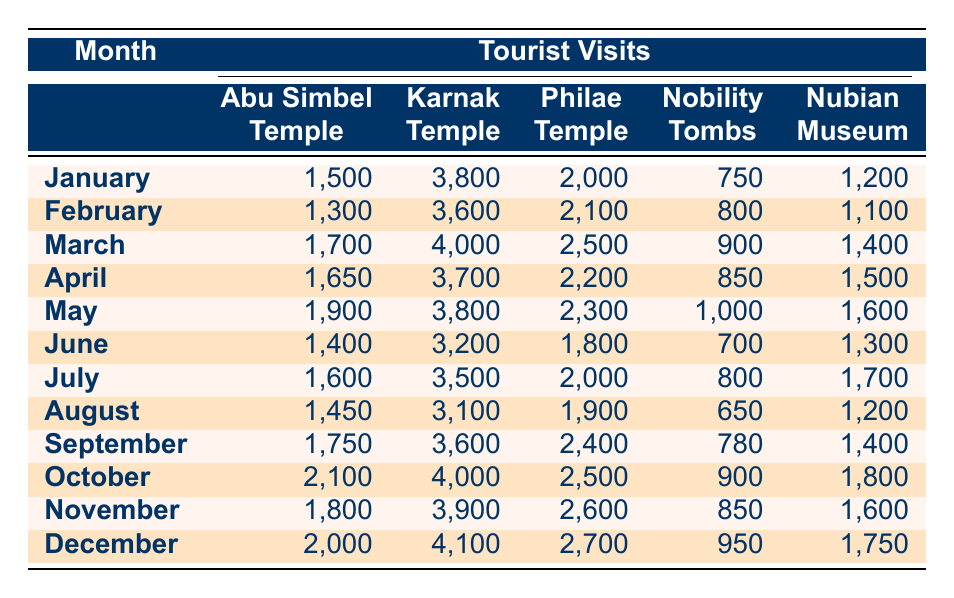What month had the highest number of visits to the Karnak Temple? In the table, I look for the maximum value under the Karnak Temple column. The highest number is 4100, which occurs in December.
Answer: December Which Nubian historical site received the least number of visitors in August? By examining the numbers in the August row, I see that the Nubian Museum received the least number of visitors with 1200.
Answer: Nubian Museum What is the total number of visits to Abu Simbel Temple from January to March? I sum the visitors: January (1500) + February (1300) + March (1700) = 4500 visitors in total.
Answer: 4500 Was there an increase in the number of visitors to the Philae Temple from June to July? I check the values: June had 1800 and July had 2000. The number has increased, confirming that more visitors came in July.
Answer: Yes What is the average number of visits to the Nobility Tombs across all months? To find the average, I add the visitors for each month: (750 + 800 + 900 + 850 + 1000 + 700 + 800 + 650 + 780 + 900 + 850 + 950) = 10,130. Then I divide this total by the number of months (12): 10,130 / 12 ≈ 844.17. Thus, the average is approximately 844.
Answer: 844 In which month did the Nubian Museum see a visitor count of 1700? Scanning through the row for July reveals that the Nubian Museum had a visitor count of 1700.
Answer: July How many more visitors did the Philae Temple receive in October compared to September? Checking the visitor counts, October had 2500 and September had 2400. The difference is 2500 - 2400 = 100 more visitors in October.
Answer: 100 Which historical site had the highest visitor count in May? Looking at the May row, I find that the Karnak Temple had the highest count with 3800 visitors.
Answer: Karnak Temple 